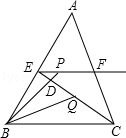In triangle ABC, given that BC is 12 units long, E and F are the midpoints of AB and AC respectively, the moving point P is on the radial EF, BP intersects CE at point D, and the bisector of angle CBP intersects CE at point Q. When CQ is 4 units long, what is the value of EP + BP? To solve this problem, visualize triangle ABC with points E and F marking the midpoints of segments AB and AC, respectively. Draw segment EF, which is parallel to side BC. Imagine point P on line EF and a line from B through P intersecting line CE at D, with the bisector of angle CBP intersecting CE at Q. Given CQ = 4, we find that EQ is twice that, at 8 units, considering triangle similarity (because EF is parallel to BC). Thus, triangle MEQ is similar to triangle BCQ, where M is the intersection of BQ extended with EF. Since the ratio of their correspondent sides is 1:2 (EQ/CQ = 2), EM, which is the whole length of EF, equals 2 times the length of BC, yielding EM = 24 units. Therefore, the sum of EP and BP equals 24 units. This enhanced explanation leverages detailed visual aids and step-by-step reasoning to facilitate understanding. 